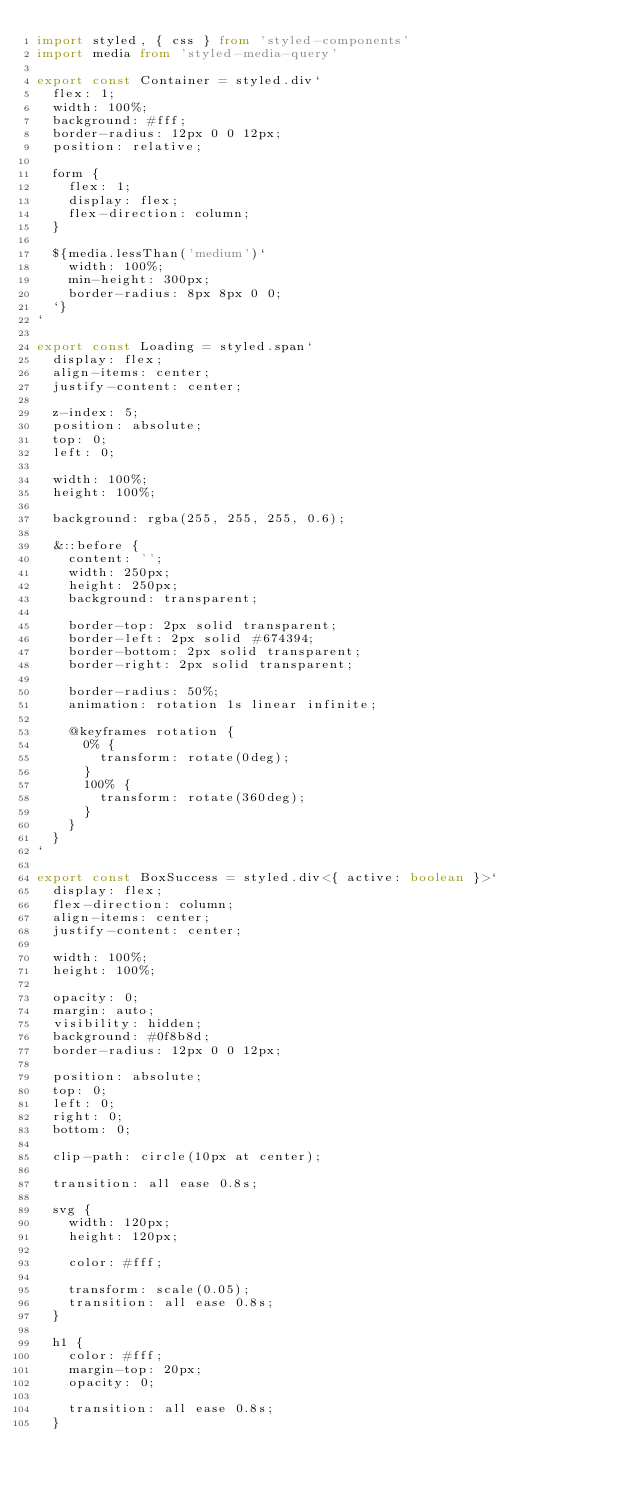<code> <loc_0><loc_0><loc_500><loc_500><_TypeScript_>import styled, { css } from 'styled-components'
import media from 'styled-media-query'

export const Container = styled.div`
  flex: 1;
  width: 100%;
  background: #fff;
  border-radius: 12px 0 0 12px;
  position: relative;

  form {
    flex: 1;
    display: flex;
    flex-direction: column;
  }

  ${media.lessThan('medium')`
    width: 100%;
    min-height: 300px;
    border-radius: 8px 8px 0 0;
  `}
`

export const Loading = styled.span`
  display: flex;
  align-items: center;
  justify-content: center;

  z-index: 5;
  position: absolute;
  top: 0;
  left: 0;

  width: 100%;
  height: 100%;

  background: rgba(255, 255, 255, 0.6);

  &::before {
    content: '';
    width: 250px;
    height: 250px;
    background: transparent;

    border-top: 2px solid transparent;
    border-left: 2px solid #674394;
    border-bottom: 2px solid transparent;
    border-right: 2px solid transparent;

    border-radius: 50%;
    animation: rotation 1s linear infinite;

    @keyframes rotation {
      0% {
        transform: rotate(0deg);
      }
      100% {
        transform: rotate(360deg);
      }
    }
  }
`

export const BoxSuccess = styled.div<{ active: boolean }>`
  display: flex;
  flex-direction: column;
  align-items: center;
  justify-content: center;

  width: 100%;
  height: 100%;

  opacity: 0;
  margin: auto;
  visibility: hidden;
  background: #0f8b8d;
  border-radius: 12px 0 0 12px;

  position: absolute;
  top: 0;
  left: 0;
  right: 0;
  bottom: 0;

  clip-path: circle(10px at center);

  transition: all ease 0.8s;

  svg {
    width: 120px;
    height: 120px;

    color: #fff;

    transform: scale(0.05);
    transition: all ease 0.8s;
  }

  h1 {
    color: #fff;
    margin-top: 20px;
    opacity: 0;

    transition: all ease 0.8s;
  }
</code> 